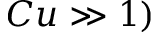Convert formula to latex. <formula><loc_0><loc_0><loc_500><loc_500>C u \gg 1 )</formula> 